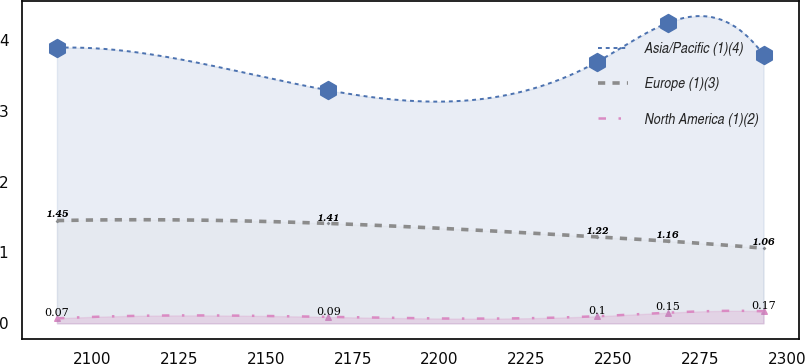Convert chart to OTSL. <chart><loc_0><loc_0><loc_500><loc_500><line_chart><ecel><fcel>Asia/Pacific (1)(4)<fcel>Europe (1)(3)<fcel>North America (1)(2)<nl><fcel>2089.96<fcel>3.89<fcel>1.45<fcel>0.07<nl><fcel>2167.96<fcel>3.29<fcel>1.41<fcel>0.09<nl><fcel>2245.3<fcel>3.69<fcel>1.22<fcel>0.1<nl><fcel>2265.62<fcel>4.24<fcel>1.16<fcel>0.15<nl><fcel>2293.16<fcel>3.79<fcel>1.06<fcel>0.17<nl></chart> 